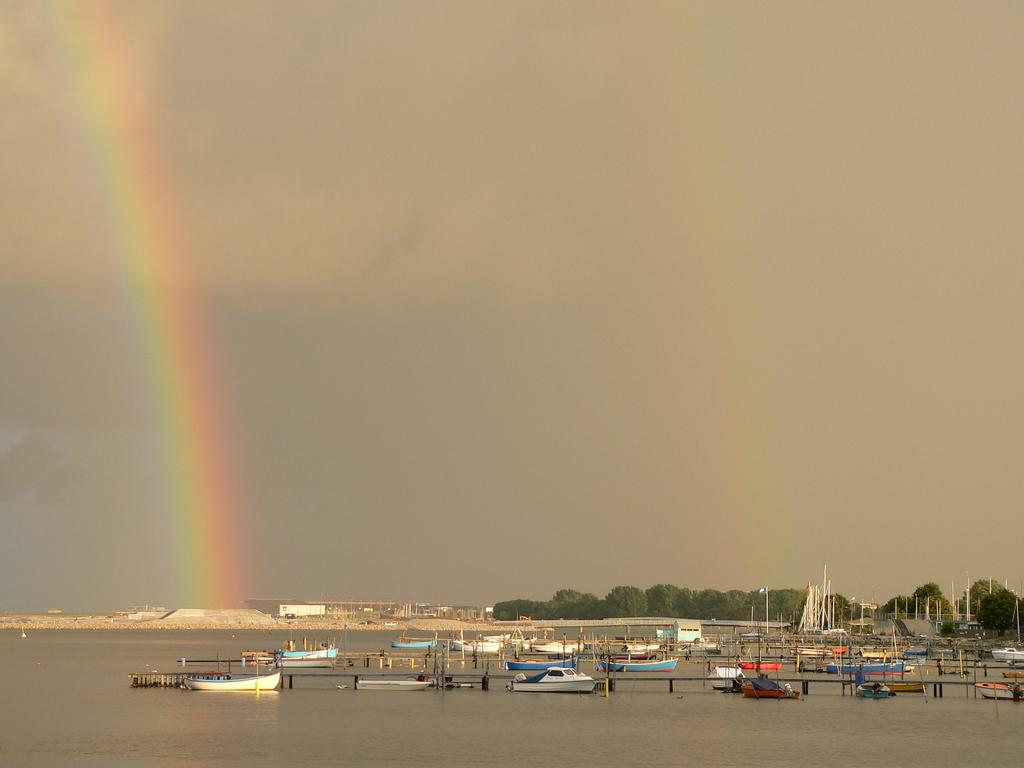What is at the bottom of the image? There is water at the bottom of the image. What is floating on the water? There are boats on the water. What can be seen in the distance in the image? There are trees and buildings in the background of the image. What part of the natural environment is visible in the image? The sky is visible in the background of the image. What type of crown is worn by the person in the cave in the image? There is no person wearing a crown in a cave in the image; it features water, boats, trees, buildings, and the sky. 